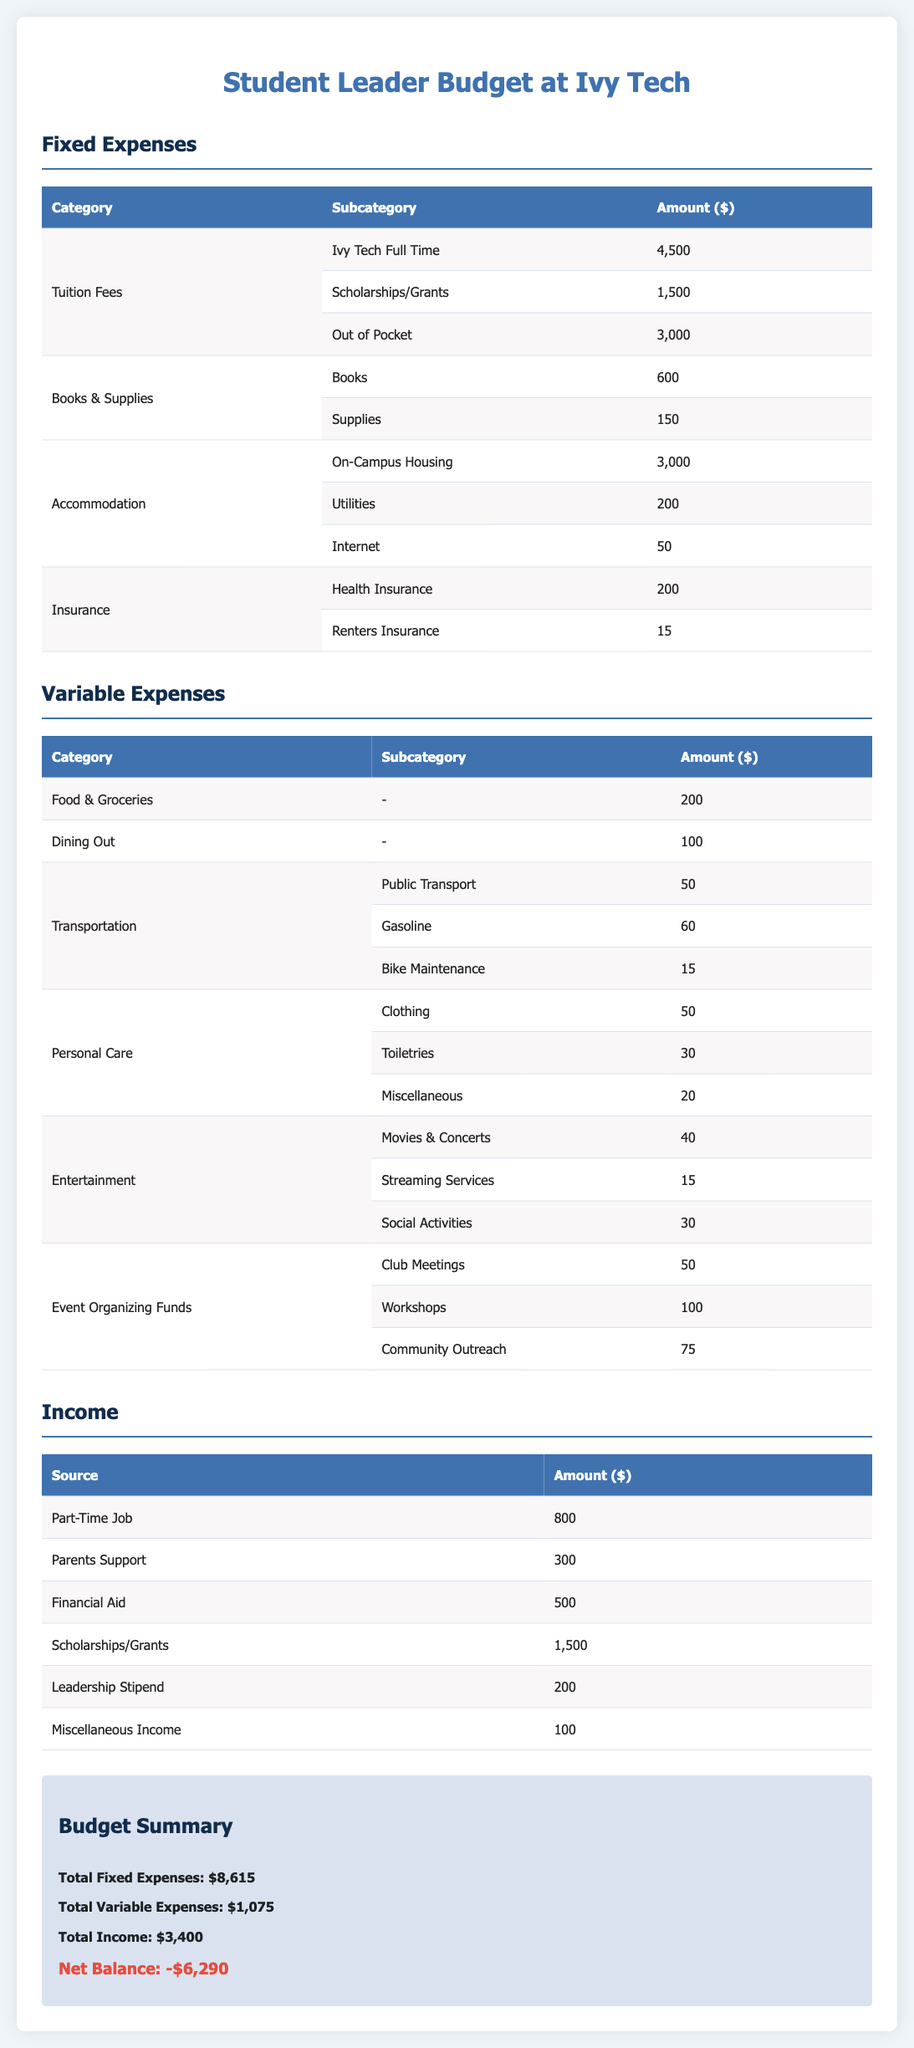What are the total fixed expenses? The total fixed expenses are calculated by summing all fixed expenses listed in the document: $4,500 + $1,500 + $3,000 + $600 + $150 + $3,000 + $200 + $50 + $200 + $15 = $8,615.
Answer: $8,615 What is the amount allocated for books? The amount allocated for books is specified in the document under Books & Supplies, which is $600.
Answer: $600 How much is the financial aid received? The document states that the financial aid received is $500.
Answer: $500 What is the income from the part-time job? The income from the part-time job is listed as $800 in the Income section of the document.
Answer: $800 What is the net balance of the budget? The net balance is calculated based on total income and expenses: $3,400 (income) - $8,615 (fixed) - $1,075 (variable) = -$6,290.
Answer: -$6,290 What are the total variable expenses? The total variable expenses are the sum of all variable expenses listed in the document, which is $1,075.
Answer: $1,075 How much is budgeted for community outreach events? The budget for community outreach under Event Organizing Funds is $75.
Answer: $75 What is the amount for on-campus housing? The document specifies the amount for on-campus housing is $3,000.
Answer: $3,000 What is the total income from scholarships and grants? The total income from scholarships and grants is $1,500 according to the Income section.
Answer: $1,500 